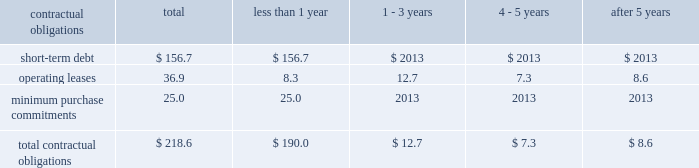Z i m m e r h o l d i n g s , i n c .
A n d s u b s i d i a r i e s 2 0 0 2 f o r m 1 0 - k contractual obligations the company has entered into contracts with various third parties in the normal course of business which will require future payments .
The table illustrates the company 2019s contractual obligations : than 1 1 - 3 4 - 5 after 5 contractual obligations total year years years years .
Critical accounting policies equipment based on historical patterns of use and physical and technological characteristics of assets , as the financial results of the company are affected by the appropriate .
In accordance with statement of financial selection and application of accounting policies and methods .
Accounting standards ( 2018 2018sfas 2019 2019 ) no .
144 , 2018 2018accounting for significant accounting policies which , in some cases , require the impairment or disposal of long-lived assets , 2019 2019 the management 2019s judgment are discussed below .
Company reviews property , plant and equipment for revenue recognition 2013 a significant portion of the com- impairment whenever events or changes in circumstances pany 2019s revenue is recognized for field based product upon indicate that the carrying value of an asset may not be notification that the product has been implanted or used .
Recoverable .
An impairment loss would be recognized for all other transactions , the company recognizes when estimated future cash flows relating to the asset revenue when title is passed to customers , generally are less than its carrying amount .
Upon shipment .
Estimated returns and allowances are derivative financial instruments 2013 critical aspects of recorded as a reduction of sales when the revenue is the company 2019s accounting policy for derivative financial recognized .
Instruments include conditions which require that critical inventories 2013 the company must determine as of each terms of a hedging instrument are essentially the same as balance sheet date how much , if any , of its inventory may a hedged forecasted transaction .
Another important ele- ultimately prove to be unsaleable or unsaleable at its ment of the policy requires that formal documentation be carrying cost .
Reserves are established to effectively maintained as required by the sfas no .
133 , 2018 2018accounting adjust any such inventory to net realizable value .
To for derivative instruments and hedging activities . 2019 2019 fail- determine the appropriate level of reserves , the company ure to comply with these conditions would result in a evaluates current stock levels in relation to historical and requirement to recognize changes in market value of expected patterns of demand for all of its products .
A hedge instruments in earnings as they occur .
Manage- series of algorithms is applied to the data to assist ment routinely monitors significant estimates , assump- management in its evaluation .
Management evaluates the tions and judgments associated with derivative need for changes to valuation reserves based on market instruments , and compliance with formal documentation conditions , competitive offerings and other factors on a requirements .
Regular basis .
Further information about inventory stock compensation 2013 the company applies the provi- reserves is provided in notes to the consolidated financial sions of apb opinion no .
25 , 2018 2018accounting for stock statements .
Issued to employees , 2019 2019 in accounting for stock-based instruments 2013 the company , as is customary in the compensation ; therefore , no compensation expense has industry , consigns surgical instruments for use in been recognized for its fixed stock option plans as orthopaedic procedures with the company 2019s products .
Options are granted at fair market value .
Sfas no .
123 , the company 2019s accounting policy requires that the full 2018 2018accounting for stock-based compensation 2019 2019 provides an cost of instruments be recognized as an expense in the alternative method of accounting for stock options based year in which the instruments are placed in service .
An on an option pricing model , such as black-scholes .
The alternative to this method is to depreciate the cost of company has adopted the disclosure requirements of instruments over their useful lives .
The company may sfas no .
123 and sfas no .
148 , 2018 2018accounting for stock- from time to time consider a change in accounting for based compensation-transition and disclosure . 2019 2019 informa- instruments to better align its accounting policy with tion regarding compensation expense under the alterna- certain company competitors .
Tive method is provided in notes to the consolidated financial statements .
Property , plant and equipment 2013 the company deter- mines estimated useful lives of property , plant and .
What percent of contractual obligations are due in less than 1 year? 
Computations: (190.0 / 218.6)
Answer: 0.86917. Z i m m e r h o l d i n g s , i n c .
A n d s u b s i d i a r i e s 2 0 0 2 f o r m 1 0 - k contractual obligations the company has entered into contracts with various third parties in the normal course of business which will require future payments .
The table illustrates the company 2019s contractual obligations : than 1 1 - 3 4 - 5 after 5 contractual obligations total year years years years .
Critical accounting policies equipment based on historical patterns of use and physical and technological characteristics of assets , as the financial results of the company are affected by the appropriate .
In accordance with statement of financial selection and application of accounting policies and methods .
Accounting standards ( 2018 2018sfas 2019 2019 ) no .
144 , 2018 2018accounting for significant accounting policies which , in some cases , require the impairment or disposal of long-lived assets , 2019 2019 the management 2019s judgment are discussed below .
Company reviews property , plant and equipment for revenue recognition 2013 a significant portion of the com- impairment whenever events or changes in circumstances pany 2019s revenue is recognized for field based product upon indicate that the carrying value of an asset may not be notification that the product has been implanted or used .
Recoverable .
An impairment loss would be recognized for all other transactions , the company recognizes when estimated future cash flows relating to the asset revenue when title is passed to customers , generally are less than its carrying amount .
Upon shipment .
Estimated returns and allowances are derivative financial instruments 2013 critical aspects of recorded as a reduction of sales when the revenue is the company 2019s accounting policy for derivative financial recognized .
Instruments include conditions which require that critical inventories 2013 the company must determine as of each terms of a hedging instrument are essentially the same as balance sheet date how much , if any , of its inventory may a hedged forecasted transaction .
Another important ele- ultimately prove to be unsaleable or unsaleable at its ment of the policy requires that formal documentation be carrying cost .
Reserves are established to effectively maintained as required by the sfas no .
133 , 2018 2018accounting adjust any such inventory to net realizable value .
To for derivative instruments and hedging activities . 2019 2019 fail- determine the appropriate level of reserves , the company ure to comply with these conditions would result in a evaluates current stock levels in relation to historical and requirement to recognize changes in market value of expected patterns of demand for all of its products .
A hedge instruments in earnings as they occur .
Manage- series of algorithms is applied to the data to assist ment routinely monitors significant estimates , assump- management in its evaluation .
Management evaluates the tions and judgments associated with derivative need for changes to valuation reserves based on market instruments , and compliance with formal documentation conditions , competitive offerings and other factors on a requirements .
Regular basis .
Further information about inventory stock compensation 2013 the company applies the provi- reserves is provided in notes to the consolidated financial sions of apb opinion no .
25 , 2018 2018accounting for stock statements .
Issued to employees , 2019 2019 in accounting for stock-based instruments 2013 the company , as is customary in the compensation ; therefore , no compensation expense has industry , consigns surgical instruments for use in been recognized for its fixed stock option plans as orthopaedic procedures with the company 2019s products .
Options are granted at fair market value .
Sfas no .
123 , the company 2019s accounting policy requires that the full 2018 2018accounting for stock-based compensation 2019 2019 provides an cost of instruments be recognized as an expense in the alternative method of accounting for stock options based year in which the instruments are placed in service .
An on an option pricing model , such as black-scholes .
The alternative to this method is to depreciate the cost of company has adopted the disclosure requirements of instruments over their useful lives .
The company may sfas no .
123 and sfas no .
148 , 2018 2018accounting for stock- from time to time consider a change in accounting for based compensation-transition and disclosure . 2019 2019 informa- instruments to better align its accounting policy with tion regarding compensation expense under the alterna- certain company competitors .
Tive method is provided in notes to the consolidated financial statements .
Property , plant and equipment 2013 the company deter- mines estimated useful lives of property , plant and .
What percent of total contractual obligations is comprised of operating leases? 
Computations: (36.9 / 218.6)
Answer: 0.1688. 